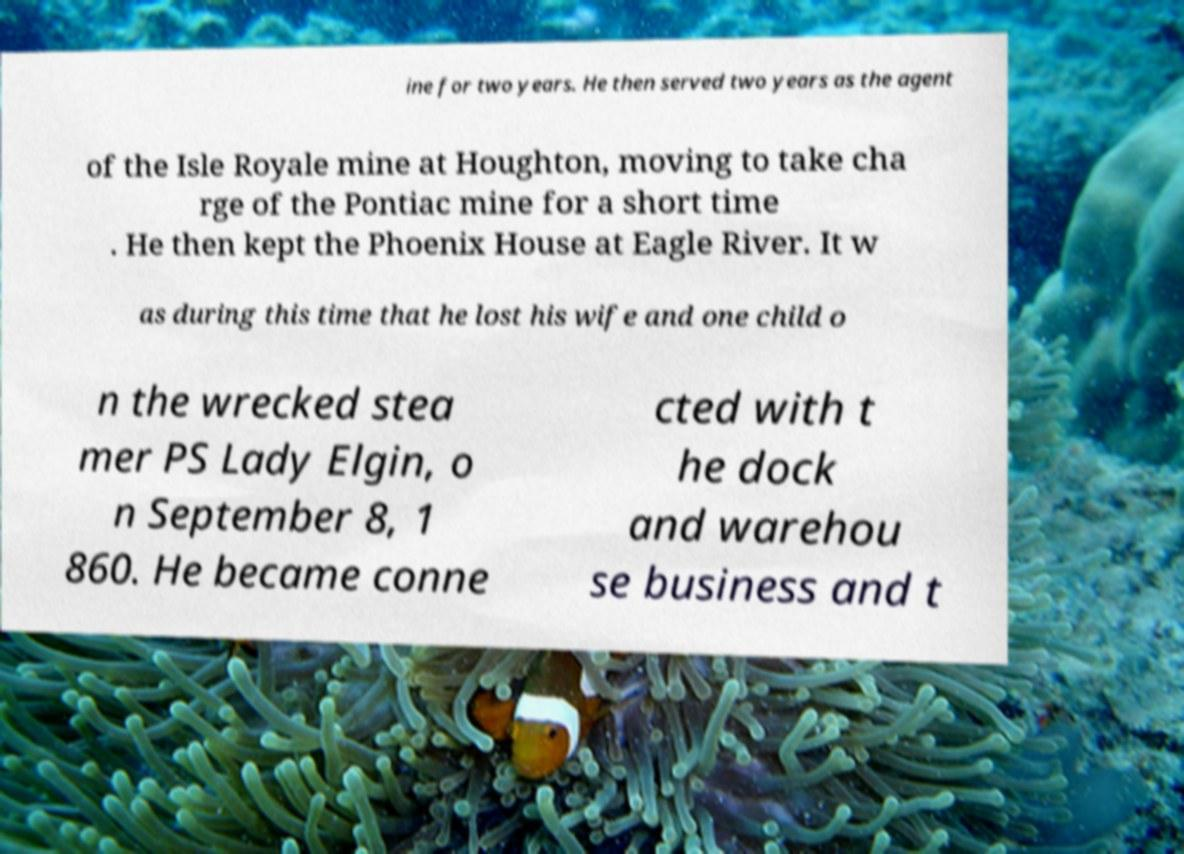Could you extract and type out the text from this image? ine for two years. He then served two years as the agent of the Isle Royale mine at Houghton, moving to take cha rge of the Pontiac mine for a short time . He then kept the Phoenix House at Eagle River. It w as during this time that he lost his wife and one child o n the wrecked stea mer PS Lady Elgin, o n September 8, 1 860. He became conne cted with t he dock and warehou se business and t 